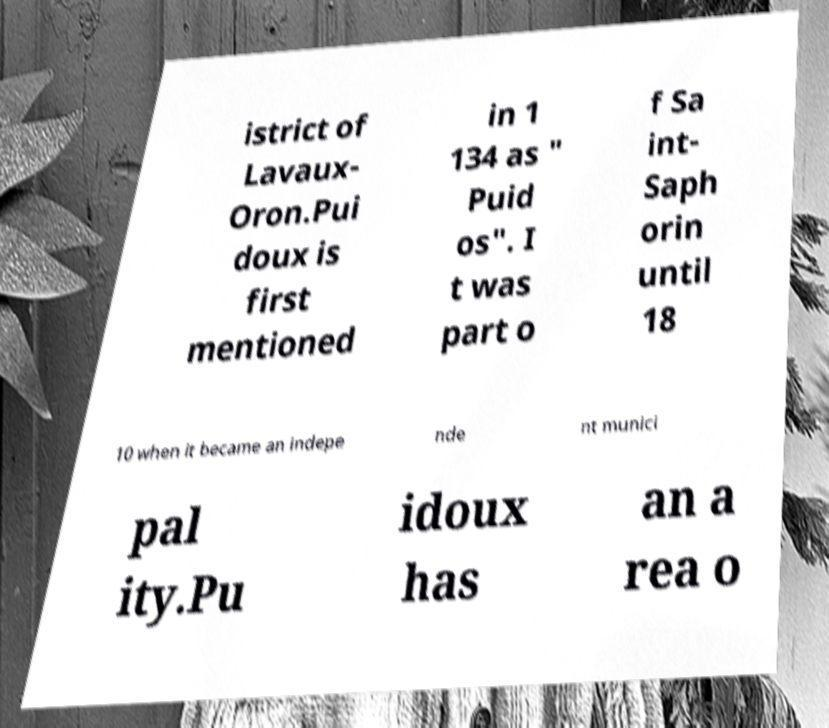Could you extract and type out the text from this image? istrict of Lavaux- Oron.Pui doux is first mentioned in 1 134 as " Puid os". I t was part o f Sa int- Saph orin until 18 10 when it became an indepe nde nt munici pal ity.Pu idoux has an a rea o 